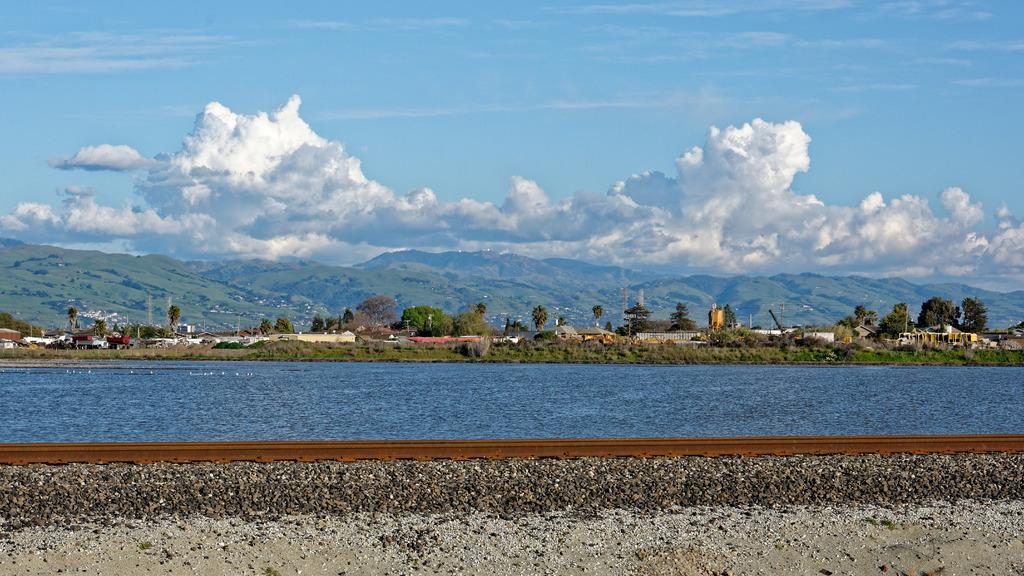What type of transportation infrastructure is present in the image? There is a railway track in the image. What natural element can be seen alongside the railway track? Water is visible in the image. What type of vegetation is in the background of the image? There are trees in the background of the image. What is visible at the top of the image? The sky is visible at the top of the image. Can you tell me how many wrens are perched on the railway track in the image? There are no wrens present in the image; it only features a railway track, water, trees, and the sky. What advice does the grandfather give to the person in the image? There is no grandfather or person present in the image, so it is not possible to answer this question. 